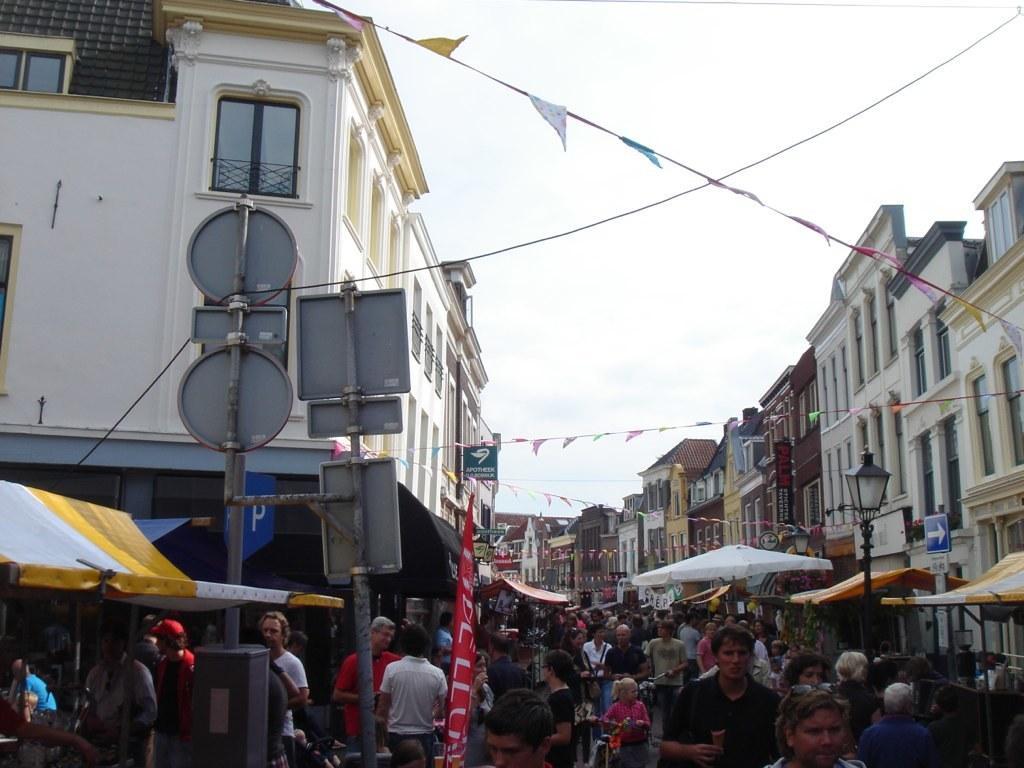Can you describe this image briefly? In this image we can see many people walking on the road, here we can see the sign boards, light poles, tents, buildings, flags, wires and the sky in the background. 